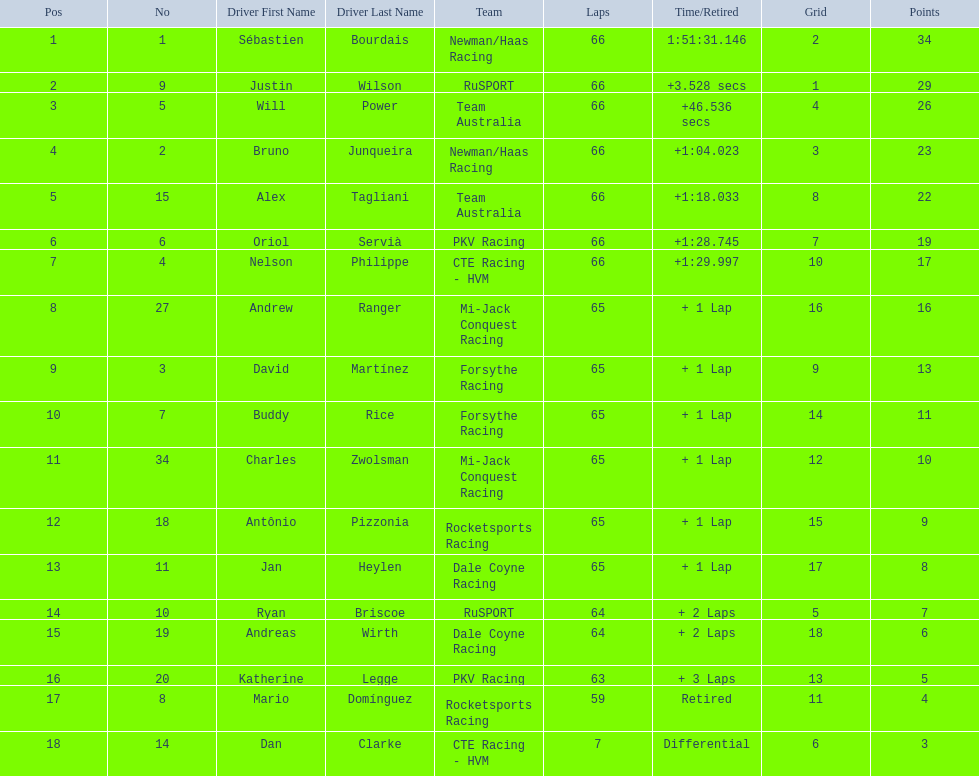How many laps did oriol servia complete at the 2006 gran premio? 66. How many laps did katherine legge complete at the 2006 gran premio? 63. Between servia and legge, who completed more laps? Oriol Servià. 